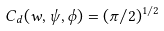<formula> <loc_0><loc_0><loc_500><loc_500>C _ { d } ( w , \psi , \phi ) = ( \pi / 2 ) ^ { 1 / 2 }</formula> 